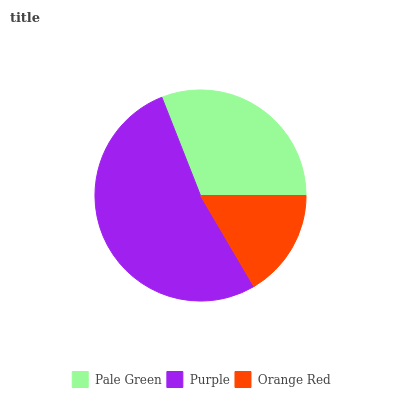Is Orange Red the minimum?
Answer yes or no. Yes. Is Purple the maximum?
Answer yes or no. Yes. Is Purple the minimum?
Answer yes or no. No. Is Orange Red the maximum?
Answer yes or no. No. Is Purple greater than Orange Red?
Answer yes or no. Yes. Is Orange Red less than Purple?
Answer yes or no. Yes. Is Orange Red greater than Purple?
Answer yes or no. No. Is Purple less than Orange Red?
Answer yes or no. No. Is Pale Green the high median?
Answer yes or no. Yes. Is Pale Green the low median?
Answer yes or no. Yes. Is Purple the high median?
Answer yes or no. No. Is Purple the low median?
Answer yes or no. No. 